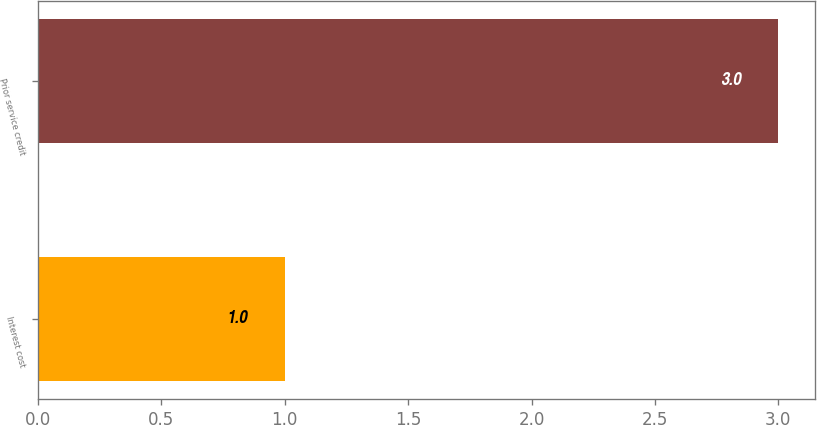<chart> <loc_0><loc_0><loc_500><loc_500><bar_chart><fcel>Interest cost<fcel>Prior service credit<nl><fcel>1<fcel>3<nl></chart> 